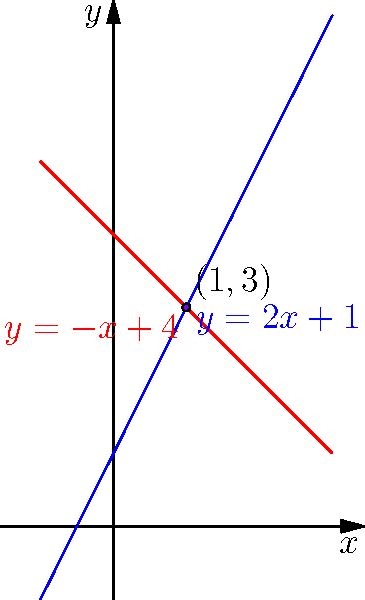In a study on screen time effects, you're analyzing data represented by two linear equations: $y = 2x + 1$ (blue line) and $y = -x + 4$ (red line). These lines represent different trends in children's cognitive performance relative to screen time. At what point do these trends intersect, potentially indicating a critical threshold in screen time's impact on cognitive function? To find the intersection point of the two lines, we need to solve the system of equations:

1) $y = 2x + 1$ (Equation 1)
2) $y = -x + 4$ (Equation 2)

At the intersection point, the $y$ values are equal, so we can set the right sides of the equations equal to each other:

3) $2x + 1 = -x + 4$

Now, let's solve for $x$:

4) $2x + x = 4 - 1$
5) $3x = 3$
6) $x = 1$

To find $y$, we can substitute $x = 1$ into either of the original equations. Let's use Equation 1:

7) $y = 2(1) + 1 = 3$

Therefore, the intersection point is $(1, 3)$.

This point represents where the two trends intersect, potentially indicating a critical threshold in screen time's impact on cognitive function at 1 hour of screen time corresponding to a cognitive performance score of 3.
Answer: $(1, 3)$ 